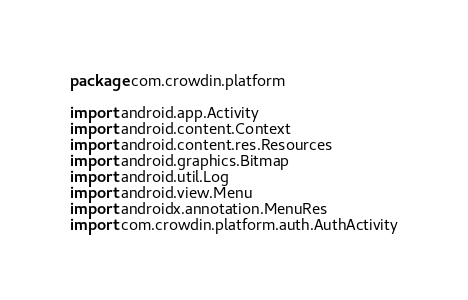Convert code to text. <code><loc_0><loc_0><loc_500><loc_500><_Kotlin_>package com.crowdin.platform

import android.app.Activity
import android.content.Context
import android.content.res.Resources
import android.graphics.Bitmap
import android.util.Log
import android.view.Menu
import androidx.annotation.MenuRes
import com.crowdin.platform.auth.AuthActivity</code> 